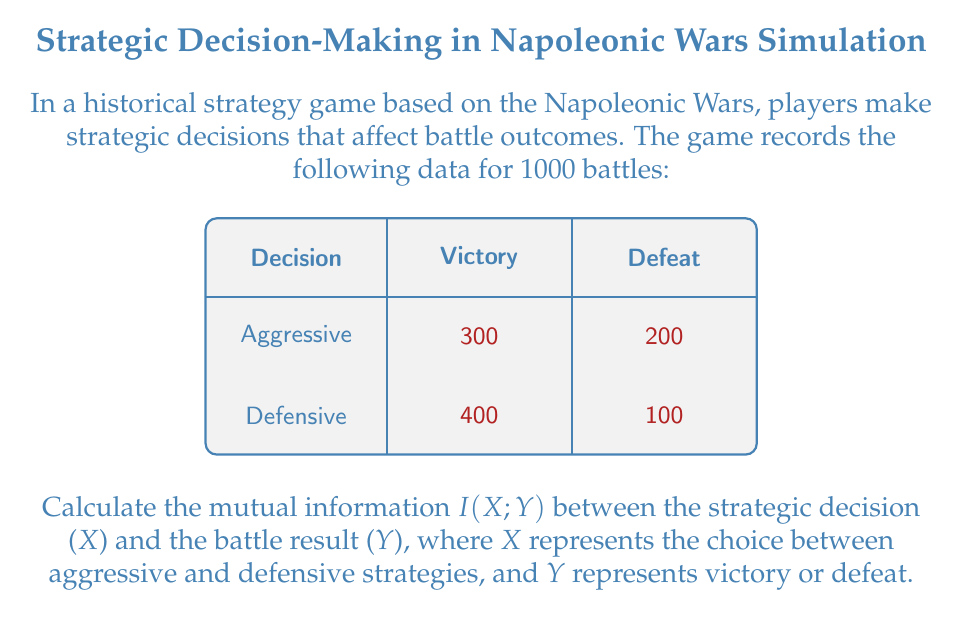Can you answer this question? To calculate the mutual information $I(X;Y)$, we'll follow these steps:

1) First, we need to calculate the probabilities:

   $P(X = \text{Aggressive}) = \frac{500}{1000} = 0.5$
   $P(X = \text{Defensive}) = \frac{500}{1000} = 0.5$
   $P(Y = \text{Victory}) = \frac{700}{1000} = 0.7$
   $P(Y = \text{Defeat}) = \frac{300}{1000} = 0.3$

   $P(X = \text{Aggressive}, Y = \text{Victory}) = \frac{300}{1000} = 0.3$
   $P(X = \text{Aggressive}, Y = \text{Defeat}) = \frac{200}{1000} = 0.2$
   $P(X = \text{Defensive}, Y = \text{Victory}) = \frac{400}{1000} = 0.4$
   $P(X = \text{Defensive}, Y = \text{Defeat}) = \frac{100}{1000} = 0.1$

2) The mutual information formula is:

   $$I(X;Y) = \sum_{x \in X} \sum_{y \in Y} P(x,y) \log_2 \frac{P(x,y)}{P(x)P(y)}$$

3) Let's calculate each term:

   $0.3 \log_2 \frac{0.3}{0.5 \cdot 0.7} = 0.3 \log_2 0.8571 = -0.0618$
   $0.2 \log_2 \frac{0.2}{0.5 \cdot 0.3} = 0.2 \log_2 1.3333 = 0.0827$
   $0.4 \log_2 \frac{0.4}{0.5 \cdot 0.7} = 0.4 \log_2 1.1429 = 0.0600$
   $0.1 \log_2 \frac{0.1}{0.5 \cdot 0.3} = 0.1 \log_2 0.6667 = -0.0541$

4) Sum all these terms:

   $I(X;Y) = -0.0618 + 0.0827 + 0.0600 - 0.0541 = 0.0268$ bits

This positive mutual information indicates that knowing the strategic decision provides some information about the battle result, and vice versa.
Answer: 0.0268 bits 